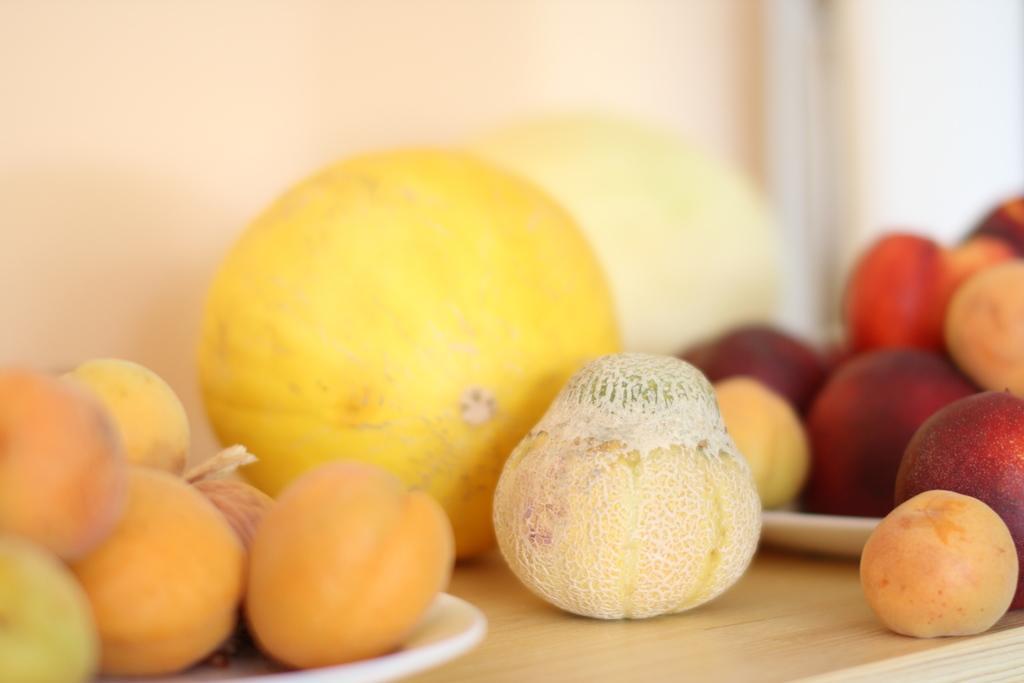Describe this image in one or two sentences. There is a wooden table. On that there are fruits. Also there are trays on the table. On the trays there are fruits. 